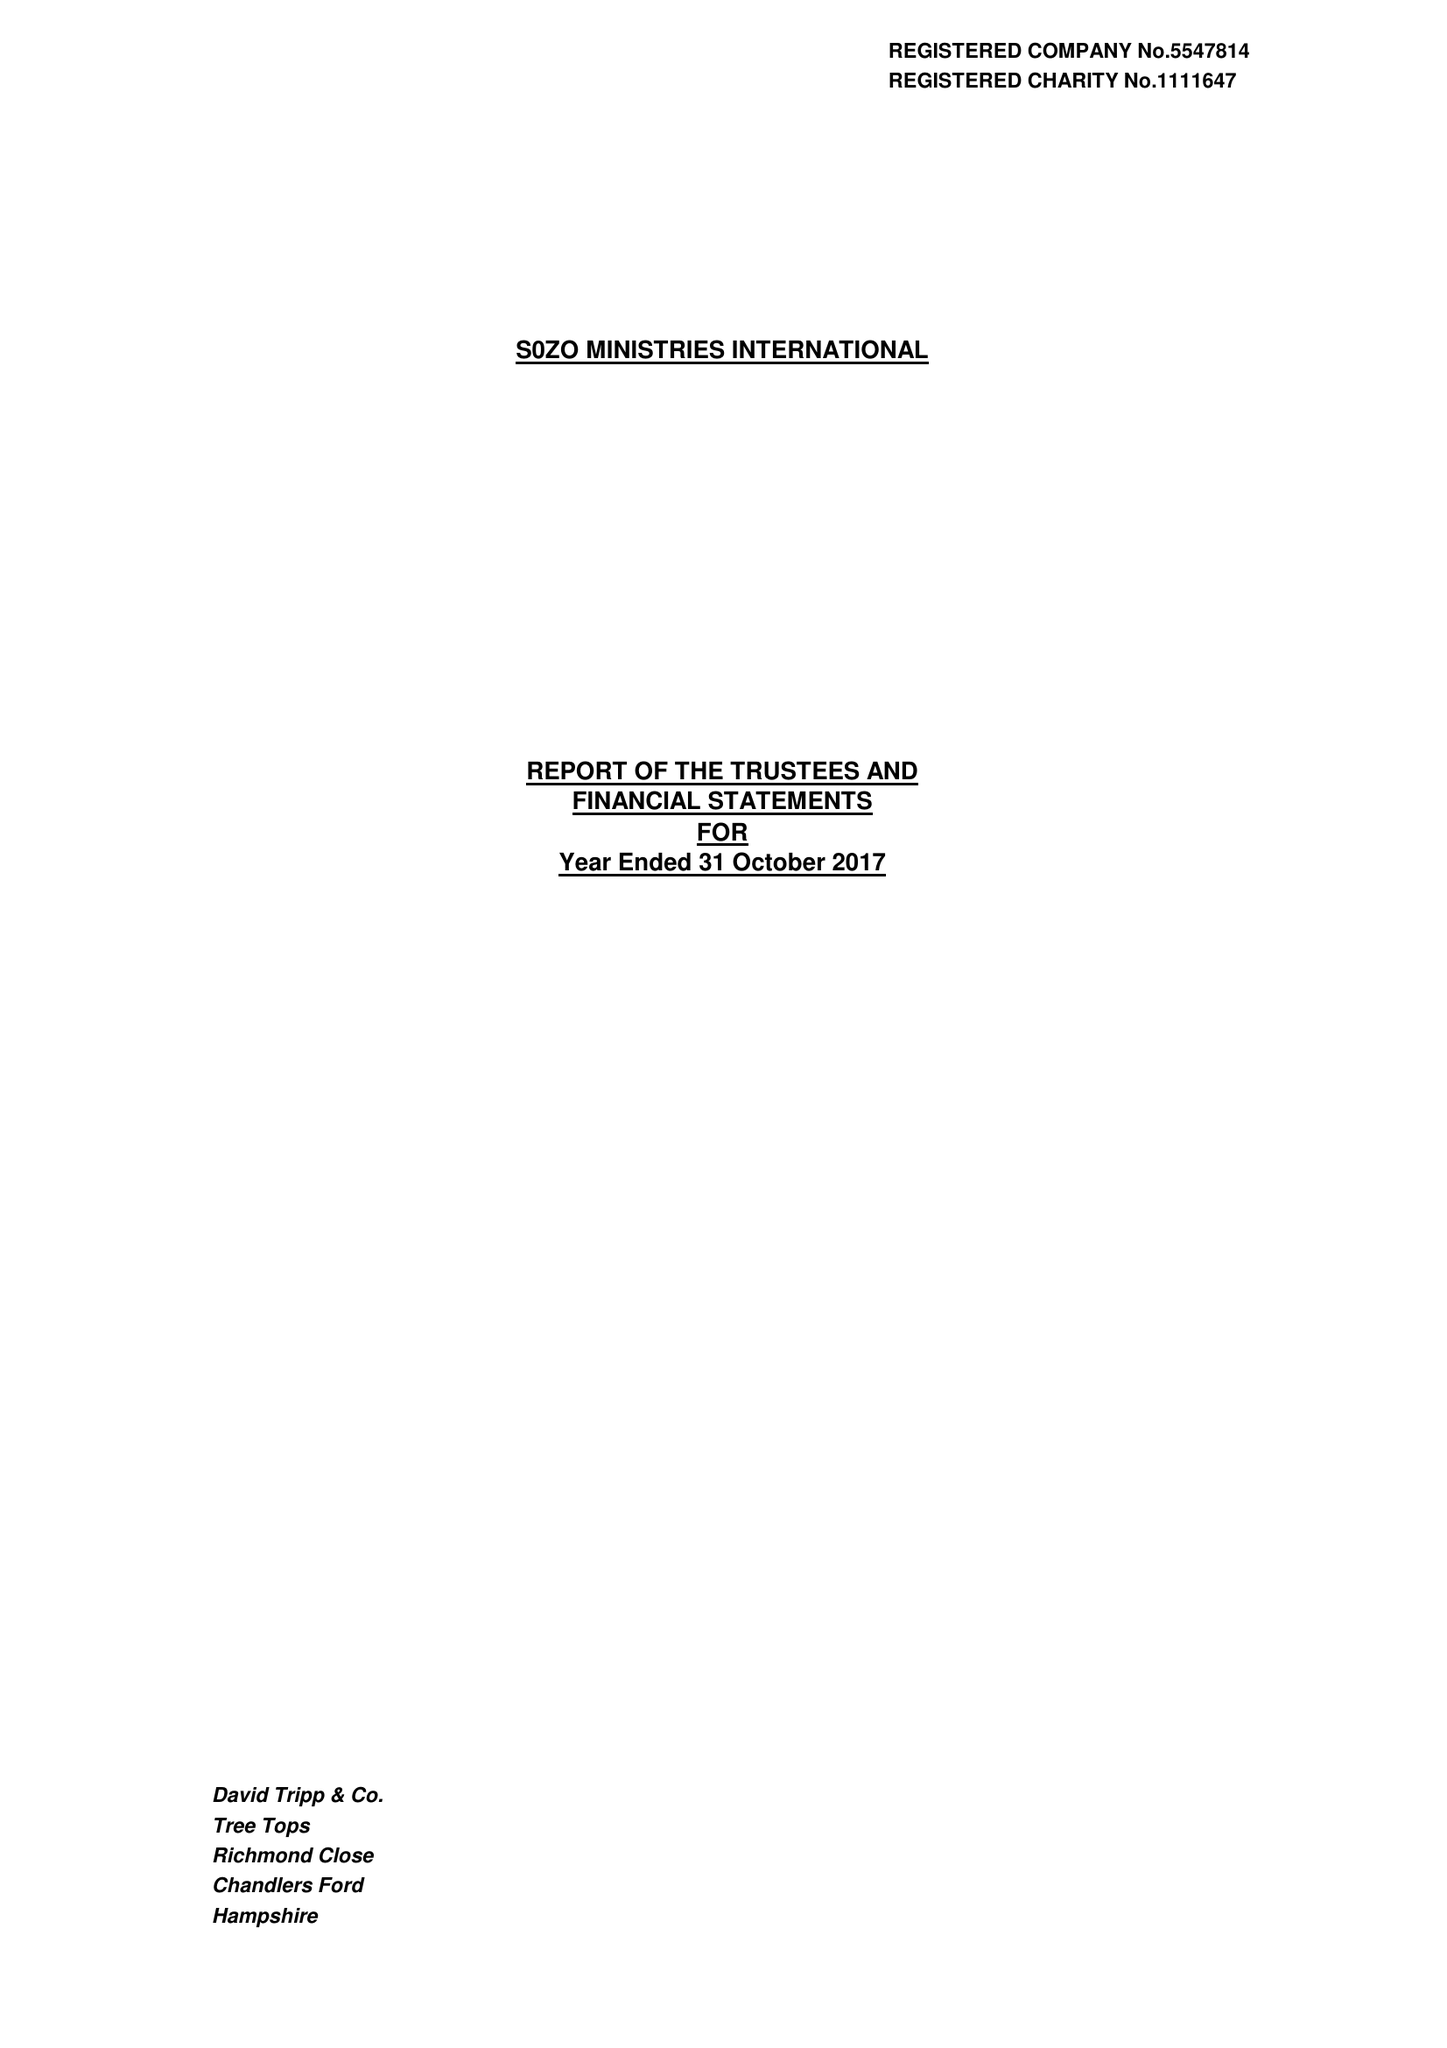What is the value for the report_date?
Answer the question using a single word or phrase. 2017-10-31 